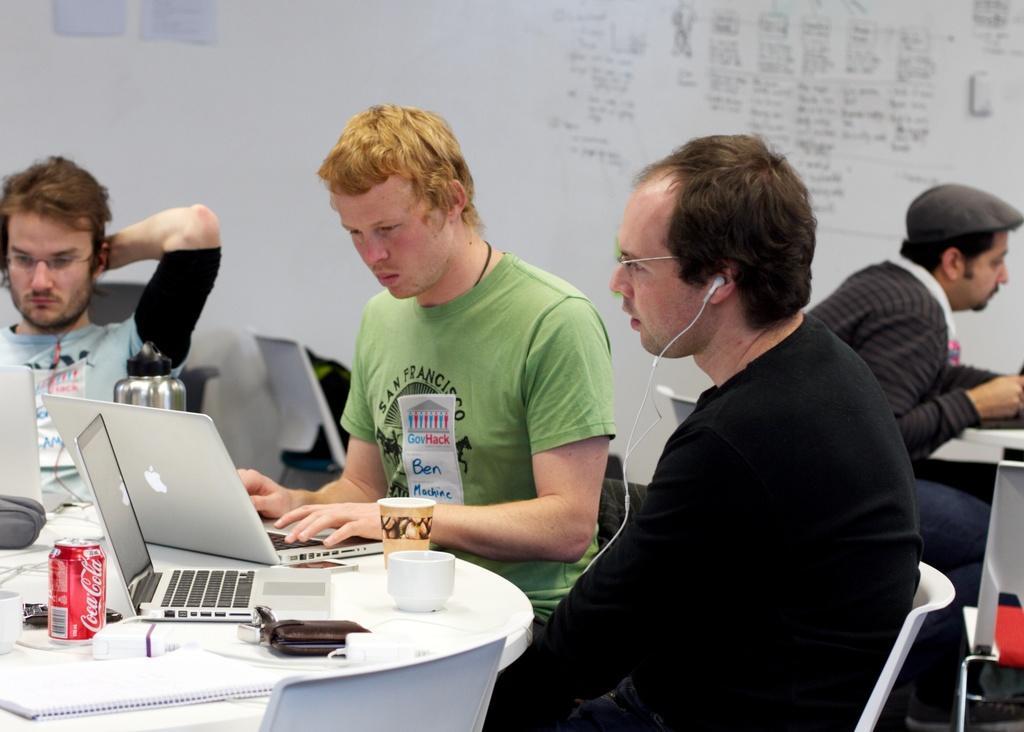Could you give a brief overview of what you see in this image? In this image we can see some persons, laptops, glass, cup, table, chairs and other objects. In the background of the image there is a person, table, wall and other objects. Something is written on the wall. 